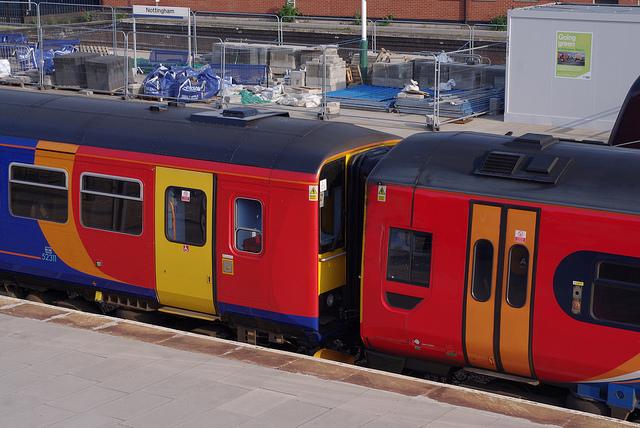What door is bright yellow?
Concise answer only. Left. Are there multiple red train cars?
Quick response, please. Yes. Is red one of the colors?
Quick response, please. Yes. 